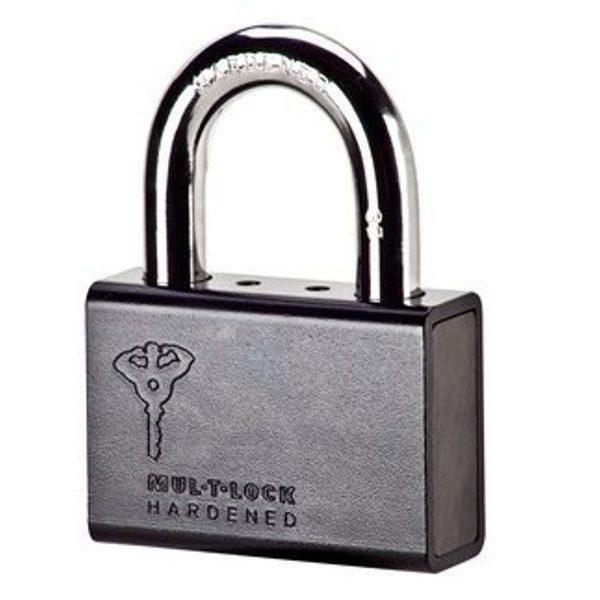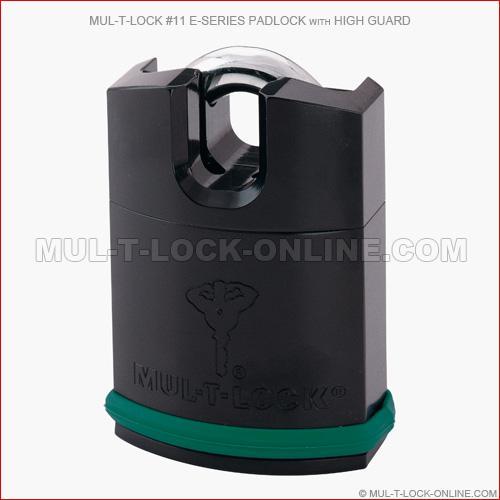The first image is the image on the left, the second image is the image on the right. Assess this claim about the two images: "there are locks with color other than silver". Correct or not? Answer yes or no. Yes. 